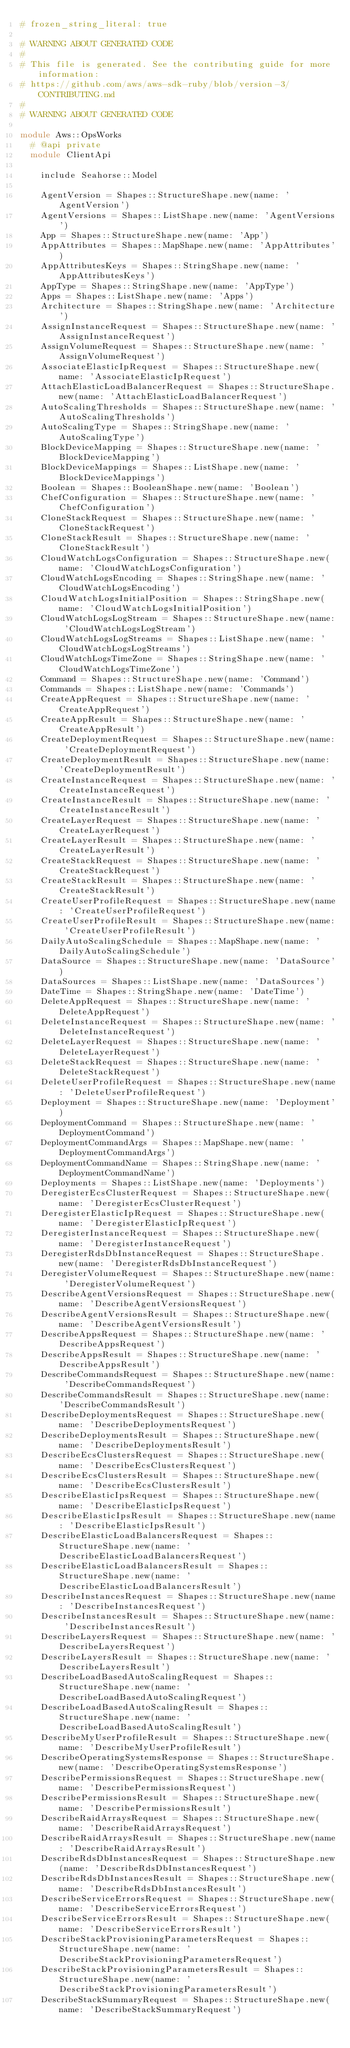<code> <loc_0><loc_0><loc_500><loc_500><_Ruby_># frozen_string_literal: true

# WARNING ABOUT GENERATED CODE
#
# This file is generated. See the contributing guide for more information:
# https://github.com/aws/aws-sdk-ruby/blob/version-3/CONTRIBUTING.md
#
# WARNING ABOUT GENERATED CODE

module Aws::OpsWorks
  # @api private
  module ClientApi

    include Seahorse::Model

    AgentVersion = Shapes::StructureShape.new(name: 'AgentVersion')
    AgentVersions = Shapes::ListShape.new(name: 'AgentVersions')
    App = Shapes::StructureShape.new(name: 'App')
    AppAttributes = Shapes::MapShape.new(name: 'AppAttributes')
    AppAttributesKeys = Shapes::StringShape.new(name: 'AppAttributesKeys')
    AppType = Shapes::StringShape.new(name: 'AppType')
    Apps = Shapes::ListShape.new(name: 'Apps')
    Architecture = Shapes::StringShape.new(name: 'Architecture')
    AssignInstanceRequest = Shapes::StructureShape.new(name: 'AssignInstanceRequest')
    AssignVolumeRequest = Shapes::StructureShape.new(name: 'AssignVolumeRequest')
    AssociateElasticIpRequest = Shapes::StructureShape.new(name: 'AssociateElasticIpRequest')
    AttachElasticLoadBalancerRequest = Shapes::StructureShape.new(name: 'AttachElasticLoadBalancerRequest')
    AutoScalingThresholds = Shapes::StructureShape.new(name: 'AutoScalingThresholds')
    AutoScalingType = Shapes::StringShape.new(name: 'AutoScalingType')
    BlockDeviceMapping = Shapes::StructureShape.new(name: 'BlockDeviceMapping')
    BlockDeviceMappings = Shapes::ListShape.new(name: 'BlockDeviceMappings')
    Boolean = Shapes::BooleanShape.new(name: 'Boolean')
    ChefConfiguration = Shapes::StructureShape.new(name: 'ChefConfiguration')
    CloneStackRequest = Shapes::StructureShape.new(name: 'CloneStackRequest')
    CloneStackResult = Shapes::StructureShape.new(name: 'CloneStackResult')
    CloudWatchLogsConfiguration = Shapes::StructureShape.new(name: 'CloudWatchLogsConfiguration')
    CloudWatchLogsEncoding = Shapes::StringShape.new(name: 'CloudWatchLogsEncoding')
    CloudWatchLogsInitialPosition = Shapes::StringShape.new(name: 'CloudWatchLogsInitialPosition')
    CloudWatchLogsLogStream = Shapes::StructureShape.new(name: 'CloudWatchLogsLogStream')
    CloudWatchLogsLogStreams = Shapes::ListShape.new(name: 'CloudWatchLogsLogStreams')
    CloudWatchLogsTimeZone = Shapes::StringShape.new(name: 'CloudWatchLogsTimeZone')
    Command = Shapes::StructureShape.new(name: 'Command')
    Commands = Shapes::ListShape.new(name: 'Commands')
    CreateAppRequest = Shapes::StructureShape.new(name: 'CreateAppRequest')
    CreateAppResult = Shapes::StructureShape.new(name: 'CreateAppResult')
    CreateDeploymentRequest = Shapes::StructureShape.new(name: 'CreateDeploymentRequest')
    CreateDeploymentResult = Shapes::StructureShape.new(name: 'CreateDeploymentResult')
    CreateInstanceRequest = Shapes::StructureShape.new(name: 'CreateInstanceRequest')
    CreateInstanceResult = Shapes::StructureShape.new(name: 'CreateInstanceResult')
    CreateLayerRequest = Shapes::StructureShape.new(name: 'CreateLayerRequest')
    CreateLayerResult = Shapes::StructureShape.new(name: 'CreateLayerResult')
    CreateStackRequest = Shapes::StructureShape.new(name: 'CreateStackRequest')
    CreateStackResult = Shapes::StructureShape.new(name: 'CreateStackResult')
    CreateUserProfileRequest = Shapes::StructureShape.new(name: 'CreateUserProfileRequest')
    CreateUserProfileResult = Shapes::StructureShape.new(name: 'CreateUserProfileResult')
    DailyAutoScalingSchedule = Shapes::MapShape.new(name: 'DailyAutoScalingSchedule')
    DataSource = Shapes::StructureShape.new(name: 'DataSource')
    DataSources = Shapes::ListShape.new(name: 'DataSources')
    DateTime = Shapes::StringShape.new(name: 'DateTime')
    DeleteAppRequest = Shapes::StructureShape.new(name: 'DeleteAppRequest')
    DeleteInstanceRequest = Shapes::StructureShape.new(name: 'DeleteInstanceRequest')
    DeleteLayerRequest = Shapes::StructureShape.new(name: 'DeleteLayerRequest')
    DeleteStackRequest = Shapes::StructureShape.new(name: 'DeleteStackRequest')
    DeleteUserProfileRequest = Shapes::StructureShape.new(name: 'DeleteUserProfileRequest')
    Deployment = Shapes::StructureShape.new(name: 'Deployment')
    DeploymentCommand = Shapes::StructureShape.new(name: 'DeploymentCommand')
    DeploymentCommandArgs = Shapes::MapShape.new(name: 'DeploymentCommandArgs')
    DeploymentCommandName = Shapes::StringShape.new(name: 'DeploymentCommandName')
    Deployments = Shapes::ListShape.new(name: 'Deployments')
    DeregisterEcsClusterRequest = Shapes::StructureShape.new(name: 'DeregisterEcsClusterRequest')
    DeregisterElasticIpRequest = Shapes::StructureShape.new(name: 'DeregisterElasticIpRequest')
    DeregisterInstanceRequest = Shapes::StructureShape.new(name: 'DeregisterInstanceRequest')
    DeregisterRdsDbInstanceRequest = Shapes::StructureShape.new(name: 'DeregisterRdsDbInstanceRequest')
    DeregisterVolumeRequest = Shapes::StructureShape.new(name: 'DeregisterVolumeRequest')
    DescribeAgentVersionsRequest = Shapes::StructureShape.new(name: 'DescribeAgentVersionsRequest')
    DescribeAgentVersionsResult = Shapes::StructureShape.new(name: 'DescribeAgentVersionsResult')
    DescribeAppsRequest = Shapes::StructureShape.new(name: 'DescribeAppsRequest')
    DescribeAppsResult = Shapes::StructureShape.new(name: 'DescribeAppsResult')
    DescribeCommandsRequest = Shapes::StructureShape.new(name: 'DescribeCommandsRequest')
    DescribeCommandsResult = Shapes::StructureShape.new(name: 'DescribeCommandsResult')
    DescribeDeploymentsRequest = Shapes::StructureShape.new(name: 'DescribeDeploymentsRequest')
    DescribeDeploymentsResult = Shapes::StructureShape.new(name: 'DescribeDeploymentsResult')
    DescribeEcsClustersRequest = Shapes::StructureShape.new(name: 'DescribeEcsClustersRequest')
    DescribeEcsClustersResult = Shapes::StructureShape.new(name: 'DescribeEcsClustersResult')
    DescribeElasticIpsRequest = Shapes::StructureShape.new(name: 'DescribeElasticIpsRequest')
    DescribeElasticIpsResult = Shapes::StructureShape.new(name: 'DescribeElasticIpsResult')
    DescribeElasticLoadBalancersRequest = Shapes::StructureShape.new(name: 'DescribeElasticLoadBalancersRequest')
    DescribeElasticLoadBalancersResult = Shapes::StructureShape.new(name: 'DescribeElasticLoadBalancersResult')
    DescribeInstancesRequest = Shapes::StructureShape.new(name: 'DescribeInstancesRequest')
    DescribeInstancesResult = Shapes::StructureShape.new(name: 'DescribeInstancesResult')
    DescribeLayersRequest = Shapes::StructureShape.new(name: 'DescribeLayersRequest')
    DescribeLayersResult = Shapes::StructureShape.new(name: 'DescribeLayersResult')
    DescribeLoadBasedAutoScalingRequest = Shapes::StructureShape.new(name: 'DescribeLoadBasedAutoScalingRequest')
    DescribeLoadBasedAutoScalingResult = Shapes::StructureShape.new(name: 'DescribeLoadBasedAutoScalingResult')
    DescribeMyUserProfileResult = Shapes::StructureShape.new(name: 'DescribeMyUserProfileResult')
    DescribeOperatingSystemsResponse = Shapes::StructureShape.new(name: 'DescribeOperatingSystemsResponse')
    DescribePermissionsRequest = Shapes::StructureShape.new(name: 'DescribePermissionsRequest')
    DescribePermissionsResult = Shapes::StructureShape.new(name: 'DescribePermissionsResult')
    DescribeRaidArraysRequest = Shapes::StructureShape.new(name: 'DescribeRaidArraysRequest')
    DescribeRaidArraysResult = Shapes::StructureShape.new(name: 'DescribeRaidArraysResult')
    DescribeRdsDbInstancesRequest = Shapes::StructureShape.new(name: 'DescribeRdsDbInstancesRequest')
    DescribeRdsDbInstancesResult = Shapes::StructureShape.new(name: 'DescribeRdsDbInstancesResult')
    DescribeServiceErrorsRequest = Shapes::StructureShape.new(name: 'DescribeServiceErrorsRequest')
    DescribeServiceErrorsResult = Shapes::StructureShape.new(name: 'DescribeServiceErrorsResult')
    DescribeStackProvisioningParametersRequest = Shapes::StructureShape.new(name: 'DescribeStackProvisioningParametersRequest')
    DescribeStackProvisioningParametersResult = Shapes::StructureShape.new(name: 'DescribeStackProvisioningParametersResult')
    DescribeStackSummaryRequest = Shapes::StructureShape.new(name: 'DescribeStackSummaryRequest')</code> 